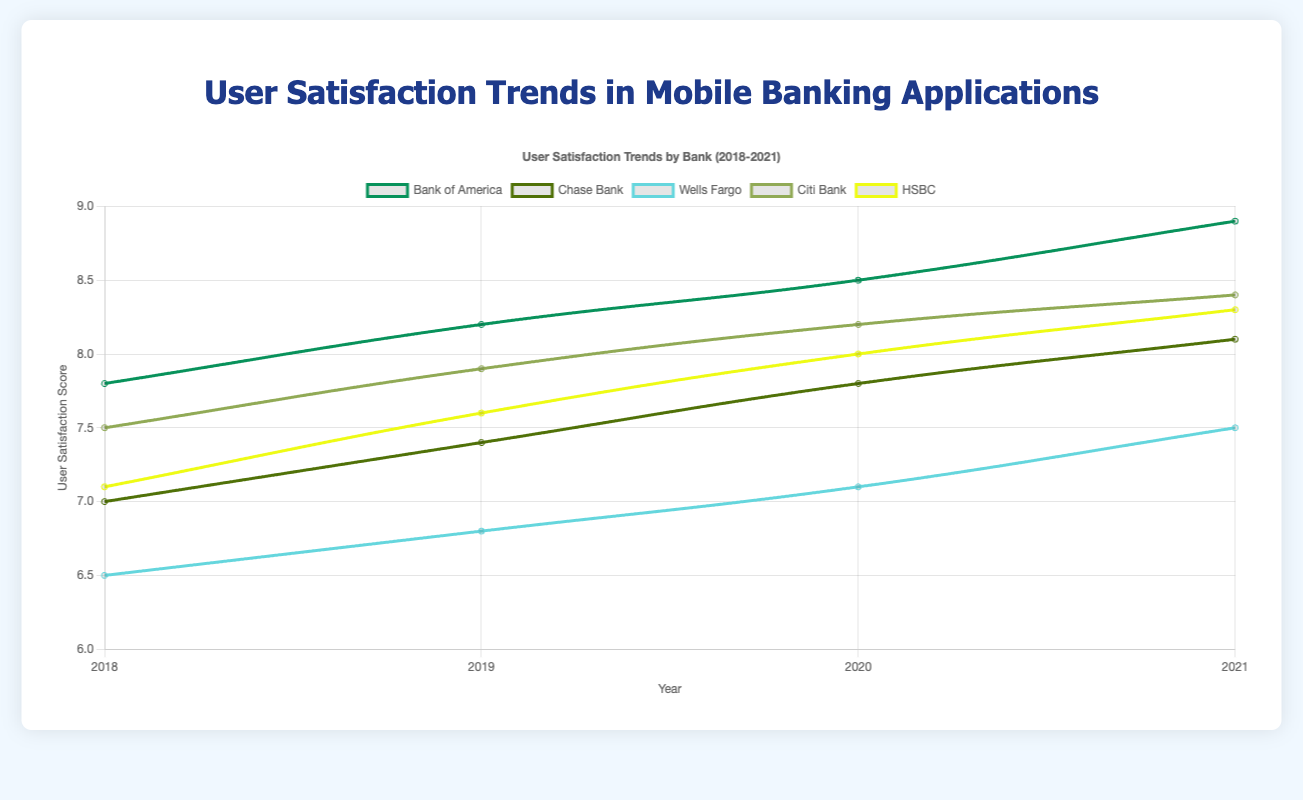Which bank has the highest user satisfaction score in 2021? To determine this, we look at the user satisfaction scores for all banks in 2021. Bank of America has 8.9, Chase Bank has 8.1, Wells Fargo has 7.5, Citi Bank has 8.4, and HSBC has 8.3. Bank of America has the highest score.
Answer: Bank of America How did the user satisfaction score for the 18-25 age group with high tech-savvy level change from 2018 to 2021 for Bank of America? We need to identify the user satisfaction scores for the specified demographic over the years. In 2018, it was 7.8; in 2019, it was 8.2; in 2020, it was 8.5; and in 2021, it was 8.9. The score steadily increased over the years.
Answer: Increased Which age group has had the most significant increase in user satisfaction at Wells Fargo from 2018 to 2021? For Wells Fargo, the 41-60 age group with low tech-savvy level had user satisfaction scores of 6.5 in 2018, 6.8 in 2019, 7.1 in 2020, and 7.5 in 2021. The increase is 7.5 - 6.5 = 1.0 from 2018 to 2021. This is the only age group in the data for Wells Fargo, so it is the most significant by default.
Answer: 41-60 Which bank showed the greatest improvement in user satisfaction for medium tech-savvy users aged 26-40 from 2018 to 2021? We should compare the satisfaction scores for medium tech-savvy users aged 26-40 across all banks. Chase Bank had 7.0 in 2018 and 8.1 in 2021, which is an increase of 1.1. Chase Bank is the only bank with this specific demographic in the data, so it has the greatest improvement.
Answer: Chase Bank What is the average user satisfaction score of Citi Bank for the 18-25 age group with medium tech-savvy level from 2018 to 2021? We calculate the average by summing the scores for Citi Bank for the specified demographic over the years, which are 7.5, 7.9, 8.2, and 8.4. The sum is 32.0 and the average is 32.0 / 4 = 8.0.
Answer: 8.0 Between HSBC and Chase Bank, which had a higher user satisfaction score in 2020 for the 26-40 age group with high tech-savvy level? We compare the scores for HSBC and Chase Bank in 2020 for users aged 26-40 with high tech-savviness. HSBC had a score of 8.0, while Chase Bank had a score of 7.8. Thus, HSBC had a higher score.
Answer: HSBC What was the increase in user satisfaction score for the 18-25 age group with high tech-savvy level at Bank of America from 2018 to 2019? For Bank of America, the user satisfaction score for the 18-25 age group with high tech-savvy level was 7.8 in 2018 and 8.2 in 2019. The increase is 8.2 - 7.8 = 0.4.
Answer: 0.4 What was the difference in user satisfaction scores between Citi Bank and Wells Fargo for the 18-25 age group with medium tech-savviness in 2021? The user satisfaction score for Citi Bank for the specified demographic in 2021 was 8.4, while Wells Fargo does not have data for this demographic in the data provided. Therefore, the comparison cannot be made.
Answer: Comparison not possible 